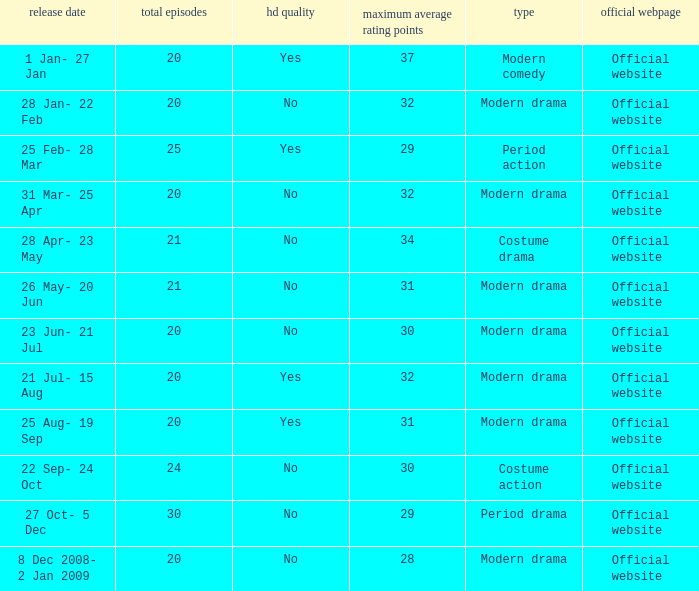Write the full table. {'header': ['release date', 'total episodes', 'hd quality', 'maximum average rating points', 'type', 'official webpage'], 'rows': [['1 Jan- 27 Jan', '20', 'Yes', '37', 'Modern comedy', 'Official website'], ['28 Jan- 22 Feb', '20', 'No', '32', 'Modern drama', 'Official website'], ['25 Feb- 28 Mar', '25', 'Yes', '29', 'Period action', 'Official website'], ['31 Mar- 25 Apr', '20', 'No', '32', 'Modern drama', 'Official website'], ['28 Apr- 23 May', '21', 'No', '34', 'Costume drama', 'Official website'], ['26 May- 20 Jun', '21', 'No', '31', 'Modern drama', 'Official website'], ['23 Jun- 21 Jul', '20', 'No', '30', 'Modern drama', 'Official website'], ['21 Jul- 15 Aug', '20', 'Yes', '32', 'Modern drama', 'Official website'], ['25 Aug- 19 Sep', '20', 'Yes', '31', 'Modern drama', 'Official website'], ['22 Sep- 24 Oct', '24', 'No', '30', 'Costume action', 'Official website'], ['27 Oct- 5 Dec', '30', 'No', '29', 'Period drama', 'Official website'], ['8 Dec 2008- 2 Jan 2009', '20', 'No', '28', 'Modern drama', 'Official website']]} What are the number of episodes when the genre is modern drama and the highest average ratings points are 28? 20.0. 